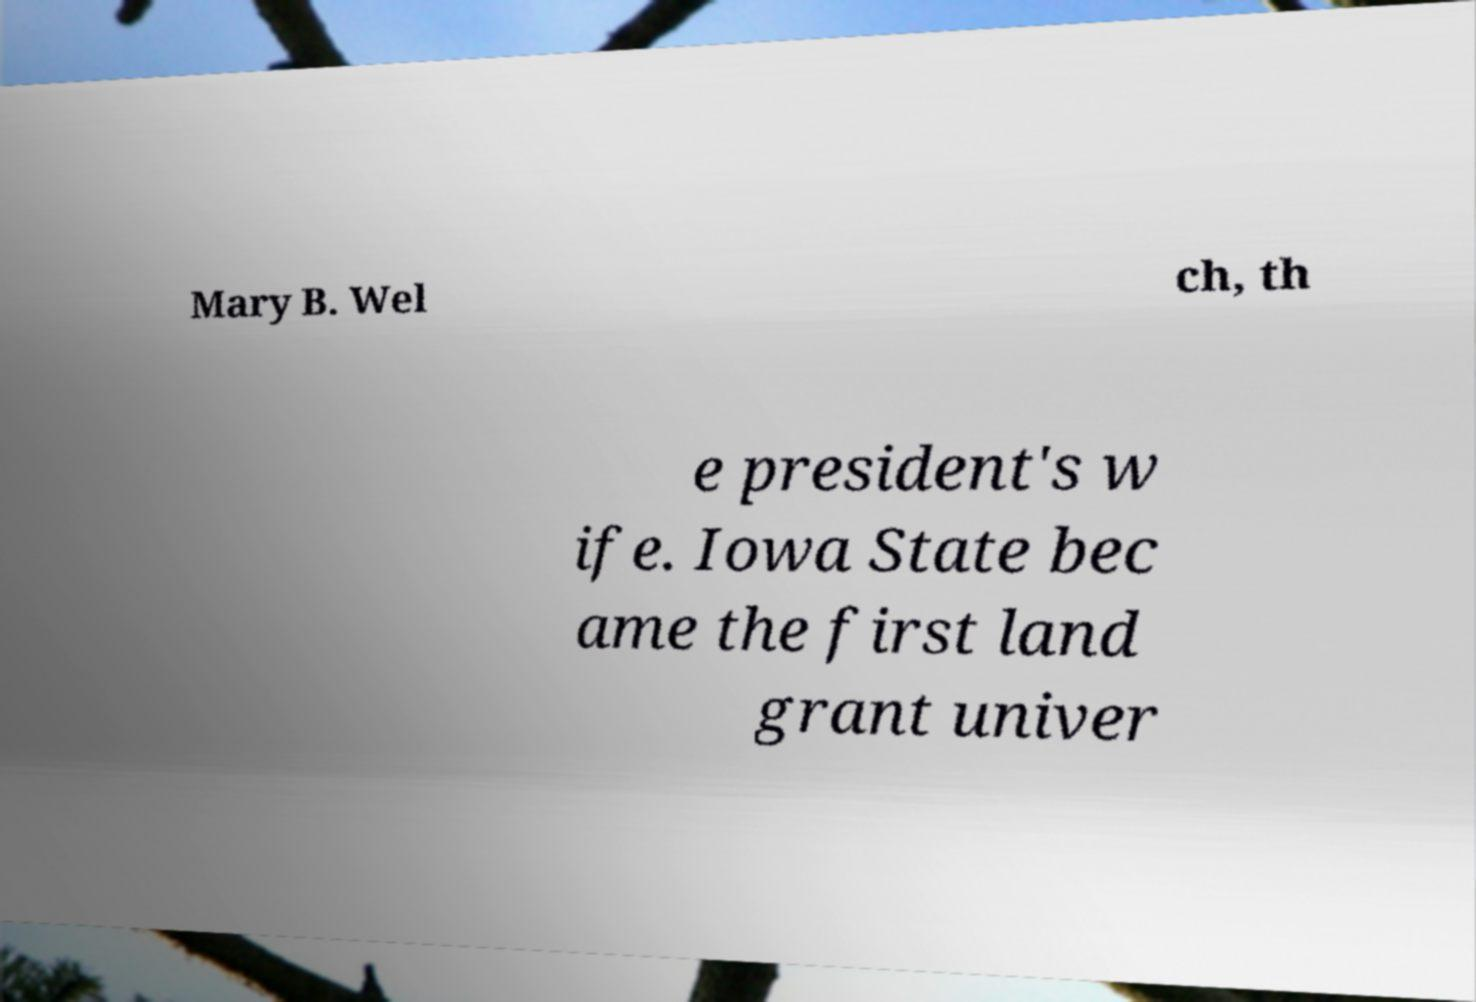Please read and relay the text visible in this image. What does it say? Mary B. Wel ch, th e president's w ife. Iowa State bec ame the first land grant univer 